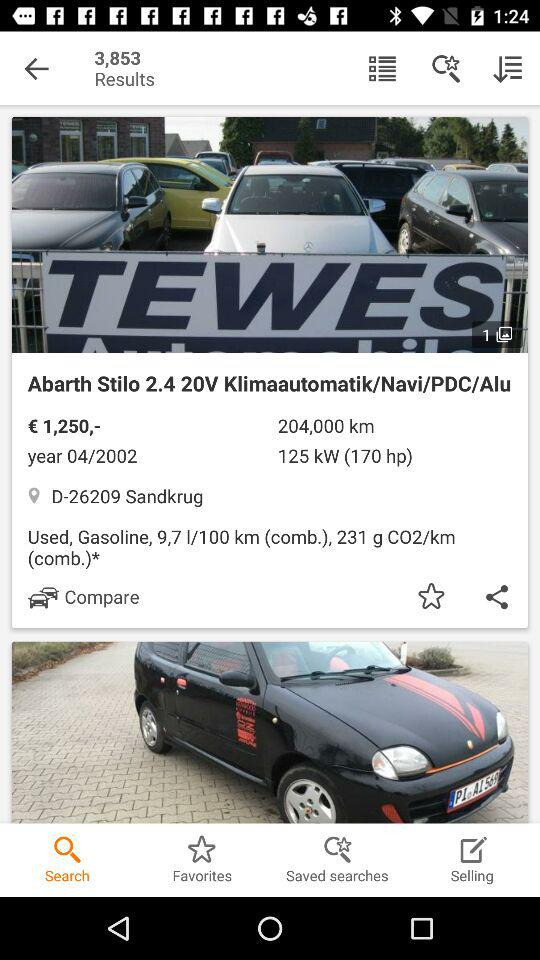What's the car's name? The car's name is Abarth Stilo 2.4 20V Klimaautomatik/Navi/PDC/Alu. 